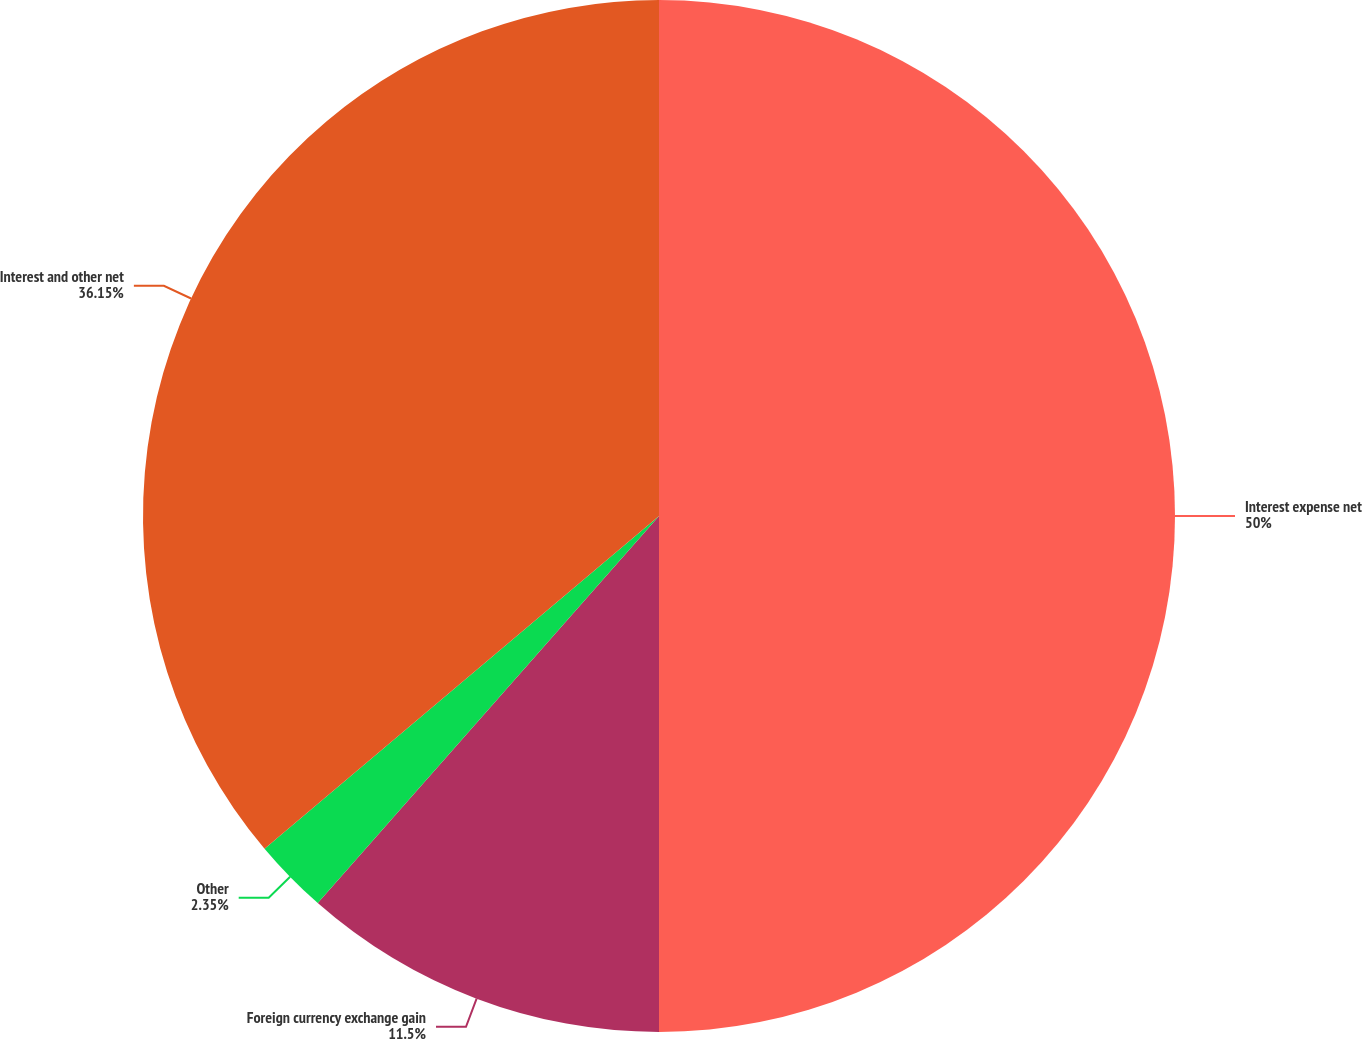Convert chart to OTSL. <chart><loc_0><loc_0><loc_500><loc_500><pie_chart><fcel>Interest expense net<fcel>Foreign currency exchange gain<fcel>Other<fcel>Interest and other net<nl><fcel>50.0%<fcel>11.5%<fcel>2.35%<fcel>36.15%<nl></chart> 